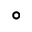<formula> <loc_0><loc_0><loc_500><loc_500>^ { \circ }</formula> 